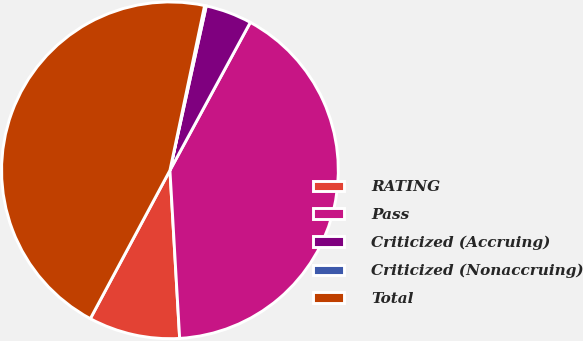Convert chart to OTSL. <chart><loc_0><loc_0><loc_500><loc_500><pie_chart><fcel>RATING<fcel>Pass<fcel>Criticized (Accruing)<fcel>Criticized (Nonaccruing)<fcel>Total<nl><fcel>8.76%<fcel>41.16%<fcel>4.46%<fcel>0.16%<fcel>45.46%<nl></chart> 